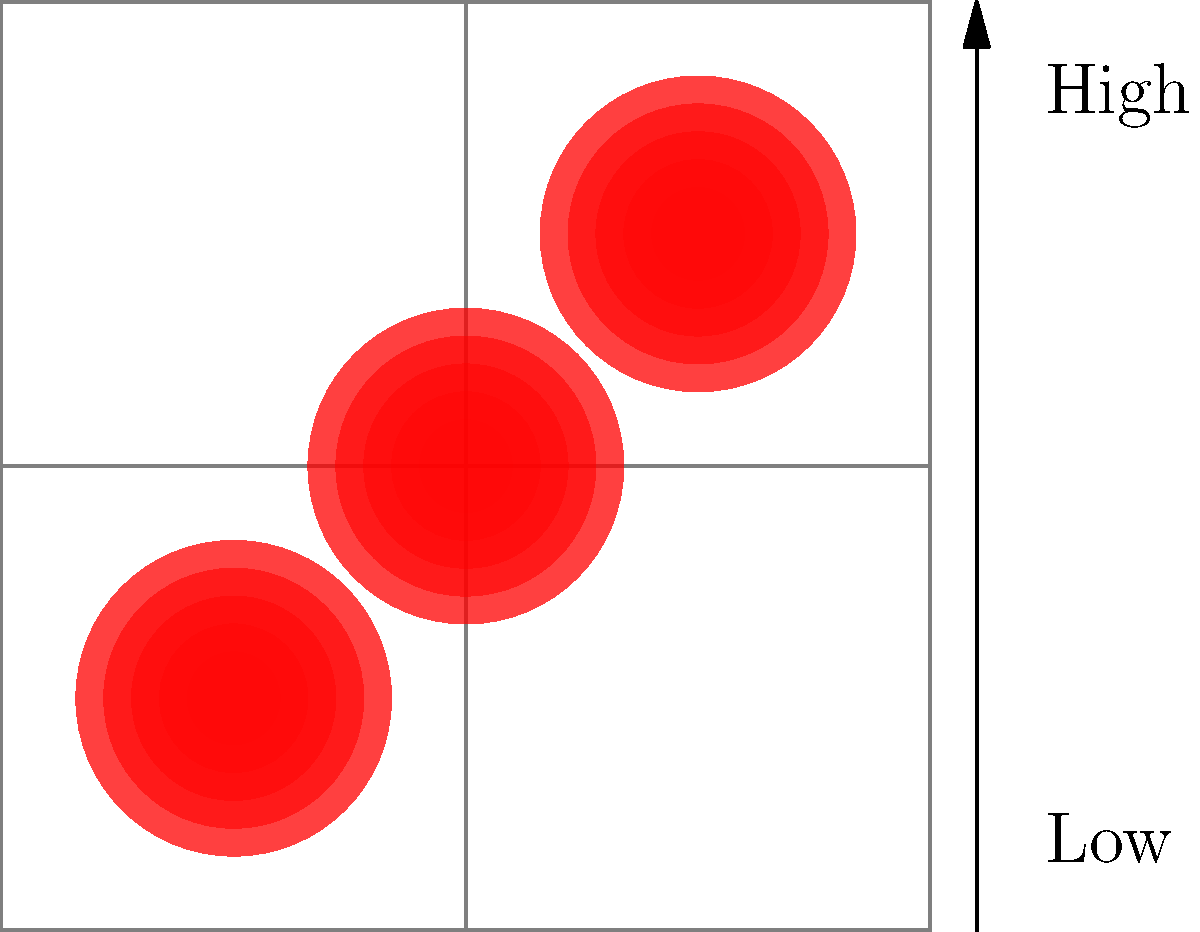Based on the heat map overlay of accident hotspots on the given road network, which intersection appears to have the highest concentration of accidents? To determine the intersection with the highest concentration of accidents, we need to analyze the heat map overlay on the road network. Let's break it down step-by-step:

1. Observe the road network:
   - The network consists of a 3x3 grid of intersections.
   - There are three horizontal and three vertical roads.

2. Identify the heat map indicators:
   - Red circular areas represent accident hotspots.
   - Darker and more intense red indicates a higher concentration of accidents.
   - Lighter and more diffuse red indicates a lower concentration of accidents.

3. Locate the accident hotspots:
   - There are three distinct hotspots visible on the map.

4. Analyze each hotspot:
   - Bottom-left hotspot: Centered near the intersection of the first horizontal and vertical roads.
   - Top-right hotspot: Centered near the intersection of the third horizontal and vertical roads.
   - Center hotspot: Centered directly on the intersection of the second horizontal and vertical roads.

5. Compare the intensity and size of the hotspots:
   - The center hotspot appears to have the darkest and most concentrated red color.
   - It is also positioned precisely at the intersection, unlike the other two hotspots.

6. Conclude:
   - The intersection at the center of the map (where the second horizontal and vertical roads meet) shows the highest concentration of accidents.
Answer: The center intersection 